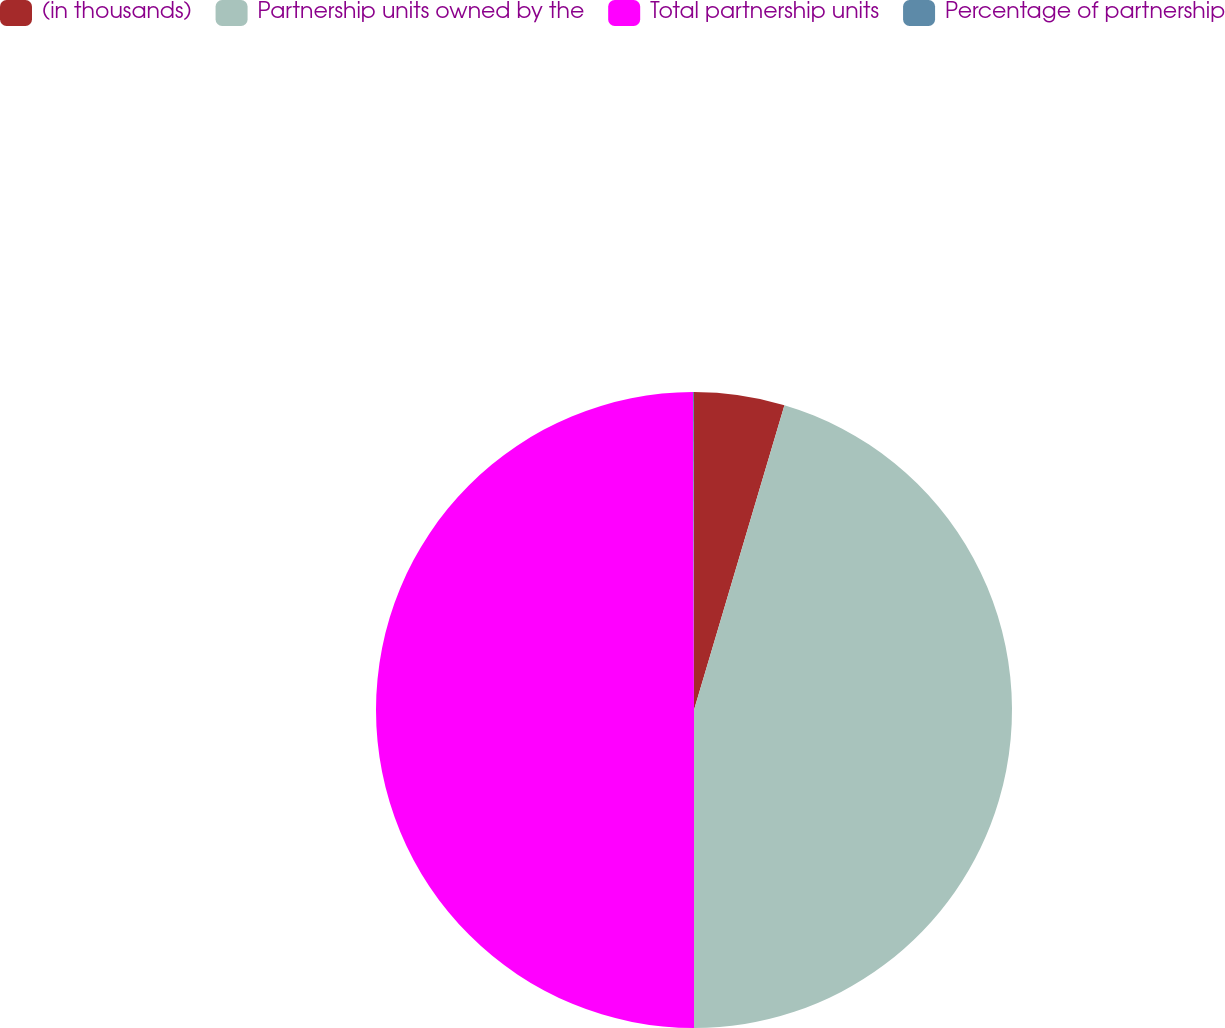<chart> <loc_0><loc_0><loc_500><loc_500><pie_chart><fcel>(in thousands)<fcel>Partnership units owned by the<fcel>Total partnership units<fcel>Percentage of partnership<nl><fcel>4.59%<fcel>45.41%<fcel>49.95%<fcel>0.05%<nl></chart> 